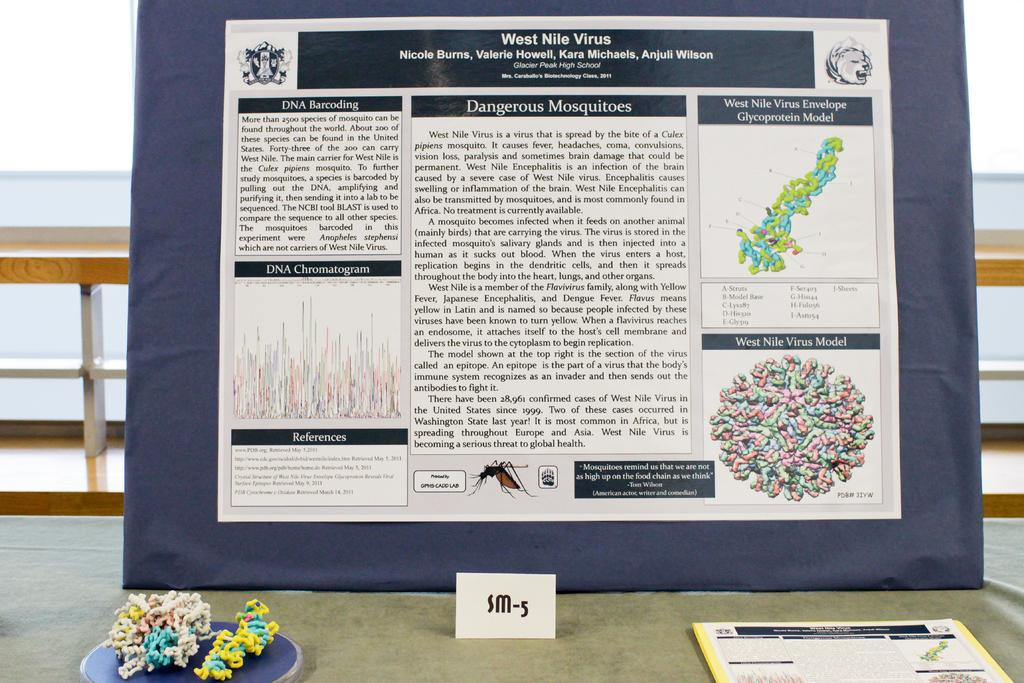Provide a one-sentence caption for the provided image. A research poster titled West Nile Virus by Nicole burns et al. is on the table outside leaning against some railing. 